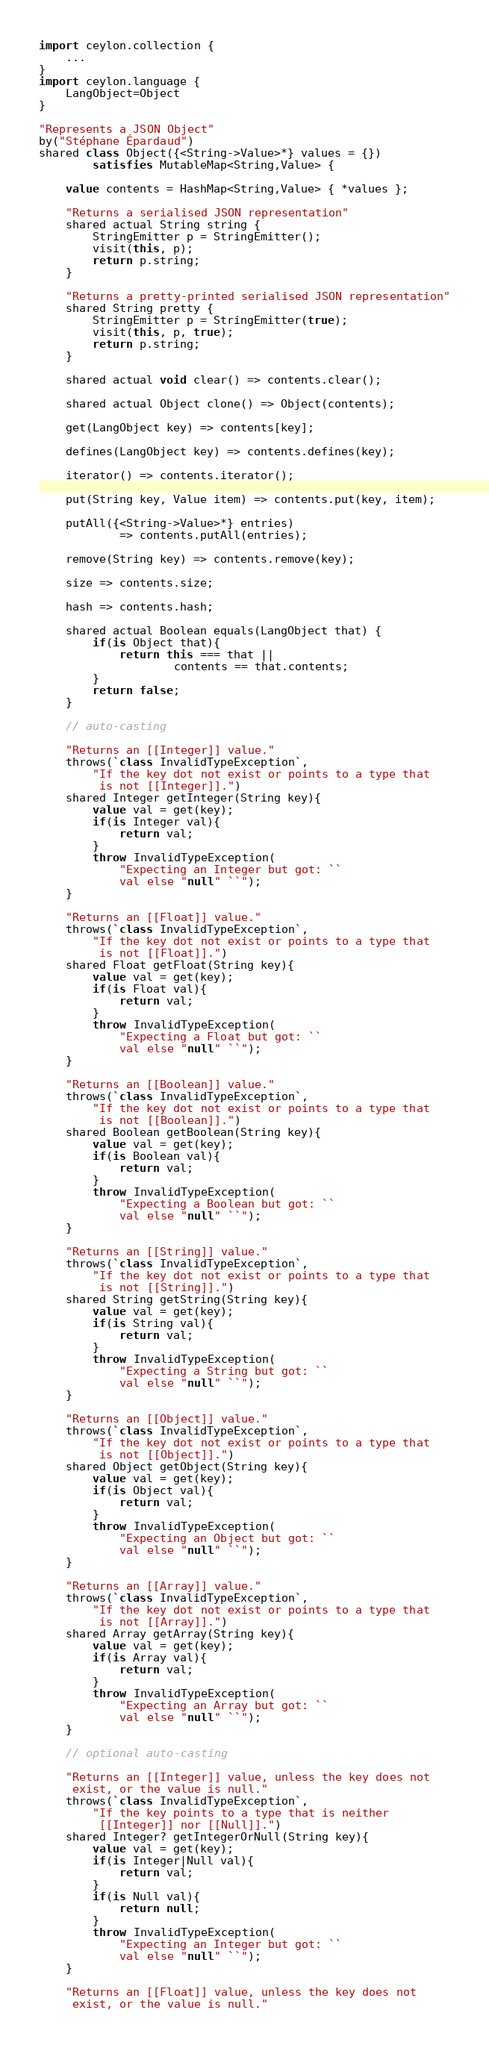<code> <loc_0><loc_0><loc_500><loc_500><_Ceylon_>import ceylon.collection {
    ...
}
import ceylon.language {
    LangObject=Object
}

"Represents a JSON Object"
by("Stéphane Épardaud")
shared class Object({<String->Value>*} values = {}) 
        satisfies MutableMap<String,Value> {
    
    value contents = HashMap<String,Value> { *values };
    
    "Returns a serialised JSON representation"
    shared actual String string {
        StringEmitter p = StringEmitter();
        visit(this, p);
        return p.string;
    }

    "Returns a pretty-printed serialised JSON representation"
    shared String pretty {
        StringEmitter p = StringEmitter(true);
        visit(this, p, true);
        return p.string;
    }
    
    shared actual void clear() => contents.clear();
    
    shared actual Object clone() => Object(contents);
    
    get(LangObject key) => contents[key];
    
    defines(LangObject key) => contents.defines(key);
    
    iterator() => contents.iterator();
    
    put(String key, Value item) => contents.put(key, item);
    
    putAll({<String->Value>*} entries) 
            => contents.putAll(entries);
    
    remove(String key) => contents.remove(key);
    
    size => contents.size;
    
    hash => contents.hash;
    
    shared actual Boolean equals(LangObject that) {
        if(is Object that){
            return this === that || 
                    contents == that.contents;
        }
        return false;
    }
    
    // auto-casting
    
    "Returns an [[Integer]] value."
    throws(`class InvalidTypeException`,
        "If the key dot not exist or points to a type that 
         is not [[Integer]].")
    shared Integer getInteger(String key){
        value val = get(key);
        if(is Integer val){
            return val;
        }
        throw InvalidTypeException(
            "Expecting an Integer but got: ``
            val else "null" ``");
    }

    "Returns an [[Float]] value."
    throws(`class InvalidTypeException`,
        "If the key dot not exist or points to a type that 
         is not [[Float]].")
    shared Float getFloat(String key){
        value val = get(key);
        if(is Float val){
            return val;
        }
        throw InvalidTypeException(
            "Expecting a Float but got: `` 
            val else "null" ``");
    }

    "Returns an [[Boolean]] value."
    throws(`class InvalidTypeException`,
        "If the key dot not exist or points to a type that 
         is not [[Boolean]].")
    shared Boolean getBoolean(String key){
        value val = get(key);
        if(is Boolean val){
            return val;
        }
        throw InvalidTypeException(
            "Expecting a Boolean but got: `` 
            val else "null" ``");
    }

    "Returns an [[String]] value."
    throws(`class InvalidTypeException`,
        "If the key dot not exist or points to a type that 
         is not [[String]].")
    shared String getString(String key){
        value val = get(key);
        if(is String val){
            return val;
        }
        throw InvalidTypeException(
            "Expecting a String but got: `` 
            val else "null" ``");
    }

    "Returns an [[Object]] value."
    throws(`class InvalidTypeException`,
        "If the key dot not exist or points to a type that 
         is not [[Object]].")
    shared Object getObject(String key){
        value val = get(key);
        if(is Object val){
            return val;
        }
        throw InvalidTypeException(
            "Expecting an Object but got: `` 
            val else "null" ``");
    }
    
    "Returns an [[Array]] value."
    throws(`class InvalidTypeException`,
        "If the key dot not exist or points to a type that 
         is not [[Array]].")
    shared Array getArray(String key){
        value val = get(key);
        if(is Array val){
            return val;
        }
        throw InvalidTypeException(
            "Expecting an Array but got: `` 
            val else "null" ``");
    }
    
    // optional auto-casting
    
    "Returns an [[Integer]] value, unless the key does not 
     exist, or the value is null."
    throws(`class InvalidTypeException`,
        "If the key points to a type that is neither 
         [[Integer]] nor [[Null]].")
    shared Integer? getIntegerOrNull(String key){
        value val = get(key);
        if(is Integer|Null val){
            return val;
        }
        if(is Null val){
            return null;
        }
        throw InvalidTypeException(
            "Expecting an Integer but got: `` 
            val else "null" ``");
    }

    "Returns an [[Float]] value, unless the key does not 
     exist, or the value is null."</code> 